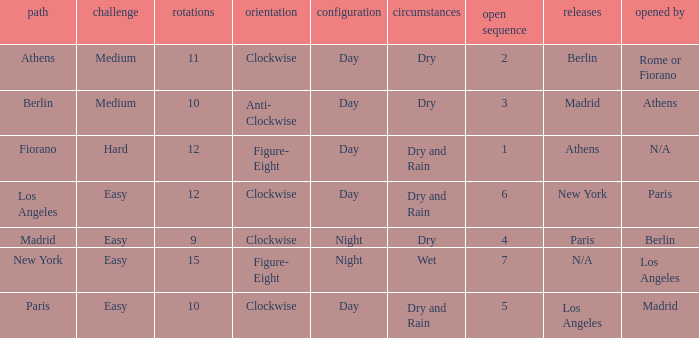What is the setting for the hard difficulty? Day. 